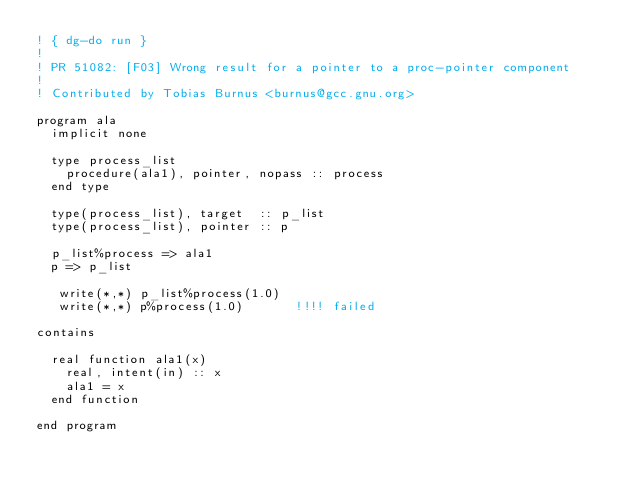Convert code to text. <code><loc_0><loc_0><loc_500><loc_500><_FORTRAN_>! { dg-do run }
!
! PR 51082: [F03] Wrong result for a pointer to a proc-pointer component
!
! Contributed by Tobias Burnus <burnus@gcc.gnu.org>

program ala
  implicit none

  type process_list
    procedure(ala1), pointer, nopass :: process
  end type

  type(process_list), target  :: p_list
  type(process_list), pointer :: p

  p_list%process => ala1
  p => p_list

   write(*,*) p_list%process(1.0)
   write(*,*) p%process(1.0)       !!!! failed

contains

  real function ala1(x)
    real, intent(in) :: x
    ala1 = x
  end function

end program
</code> 